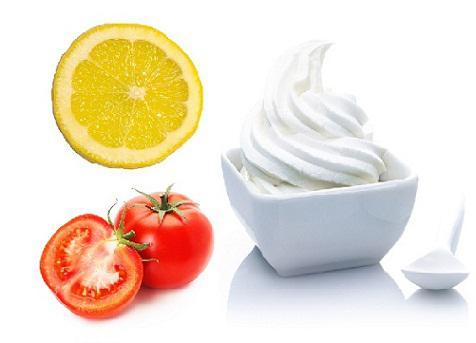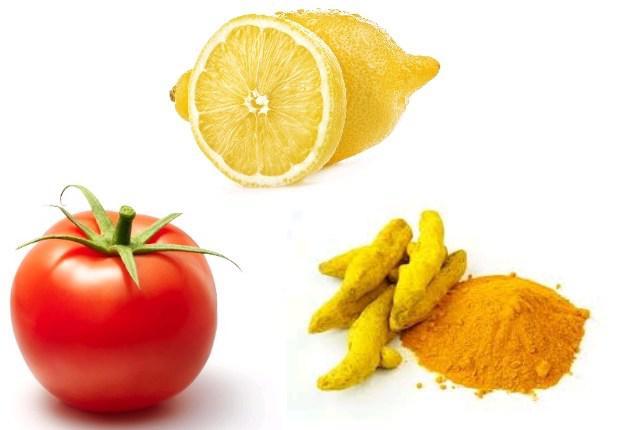The first image is the image on the left, the second image is the image on the right. For the images shown, is this caption "There is a whole un cut tomato next to lemon and whole turmeric root which is next to the powdered turmeric" true? Answer yes or no. Yes. The first image is the image on the left, the second image is the image on the right. Considering the images on both sides, is "The left image includes at least one whole tomato and whole lemon, and exactly one bowl of grain." valid? Answer yes or no. No. 